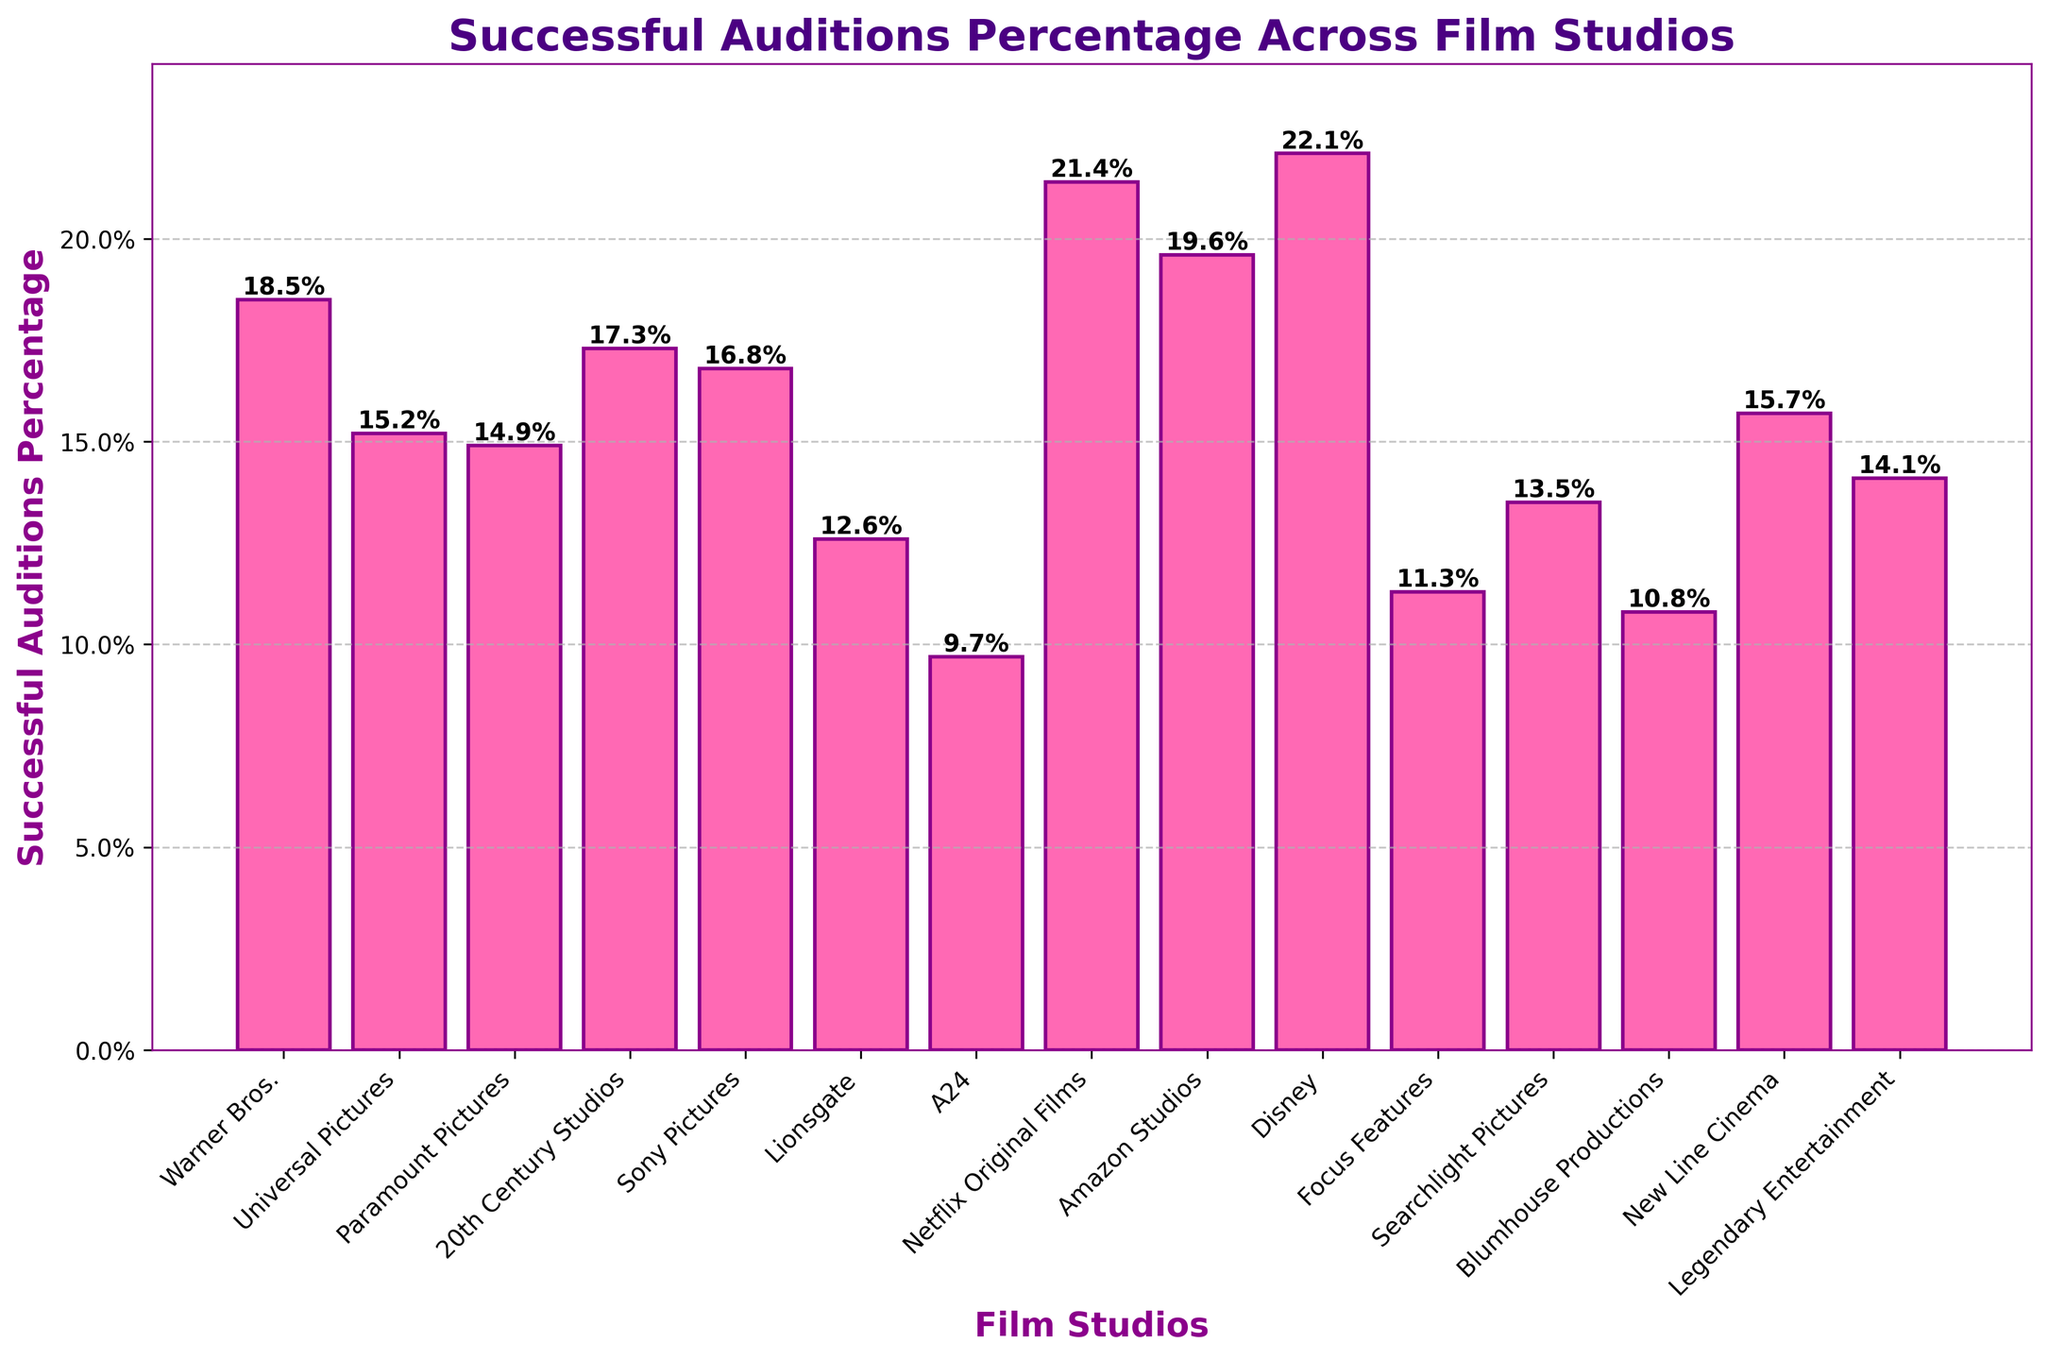Which film studio has the highest percentage of successful auditions? By looking at the height of the bars, Disney has the highest bar, indicating it has the highest percentage of successful auditions at 22.1%.
Answer: Disney Which film studio has the lowest percentage of successful auditions? By examining the shortest bar on the chart, A24 has the lowest bar, with a percentage of 9.7%.
Answer: A24 How much higher is the successful audition percentage of Disney compared to Lionsgate? Disney has a percentage of 22.1% and Lionsgate has 12.6%. Subtract the smaller from the larger: 22.1% - 12.6% = 9.5%.
Answer: 9.5% What is the average successful audition percentage of Warner Bros., Universal Pictures, and Paramount Pictures? Sum their percentages (18.5 + 15.2 + 14.9) and then divide by the number of studios: (18.5 + 15.2 + 14.9) / 3 = 48.6 / 3 = 16.2%.
Answer: 16.2% Which studios have a successful audition percentage greater than 20%? The bars for Netflix Original Films, Amazon Studios, and Disney are all above the 20% mark, corresponding to successful audition percentages of 21.4%, 19.6%, and 22.1% respectively.
Answer: Netflix Original Films, Disney Compare the percentage of successful auditions between Searchlight Pictures and Blumhouse Productions. Which one is higher and by how much? Searchlight Pictures is at 13.5% and Blumhouse Productions is at 10.8%. The difference is 13.5% - 10.8% = 2.7%, and Searchlight Pictures is higher.
Answer: Searchlight Pictures, 2.7% What visual attribute helps differentiate the bars on the chart for better readability? The x-axis labels are rotated at an angle to ensure they are not overlapping and are easily readable.
Answer: Rotation of x-axis labels If you combine the successful audition percentages of A24 and Focus Features, what would be the total percentage? Add the two percentages: 9.7% (A24) + 11.3% (Focus Features) = 21.0%.
Answer: 21.0% Which studios have a successful audition percentage between 15% and 20%? The bars for Warner Bros., 20th Century Studios, Sony Pictures, New Line Cinema, and Amazon Studios hover between the 15% and 20% range. Their exact percentages are 18.5%, 17.3%, 16.8%, 15.7%, and 19.6%, respectively.
Answer: Warner Bros., 20th Century Studios, Sony Pictures, New Line Cinema, Amazon Studios 